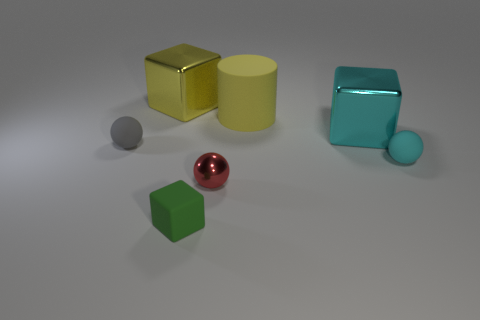Is there another red shiny object that has the same shape as the red metallic object?
Offer a terse response. No. What color is the shiny ball that is the same size as the gray object?
Make the answer very short. Red. There is a cyan object that is in front of the small gray sphere; what is it made of?
Provide a short and direct response. Rubber. There is a cyan object behind the gray thing; is it the same shape as the metal thing that is in front of the tiny cyan ball?
Make the answer very short. No. Are there the same number of red balls that are behind the cyan matte object and large brown shiny balls?
Provide a succinct answer. Yes. How many tiny gray things are the same material as the small cyan sphere?
Provide a short and direct response. 1. What is the color of the other cube that is the same material as the big yellow block?
Provide a succinct answer. Cyan. Is the size of the yellow matte cylinder the same as the matte sphere on the right side of the small gray matte object?
Ensure brevity in your answer.  No. The green rubber object has what shape?
Ensure brevity in your answer.  Cube. How many matte spheres are the same color as the small metallic sphere?
Provide a succinct answer. 0. 